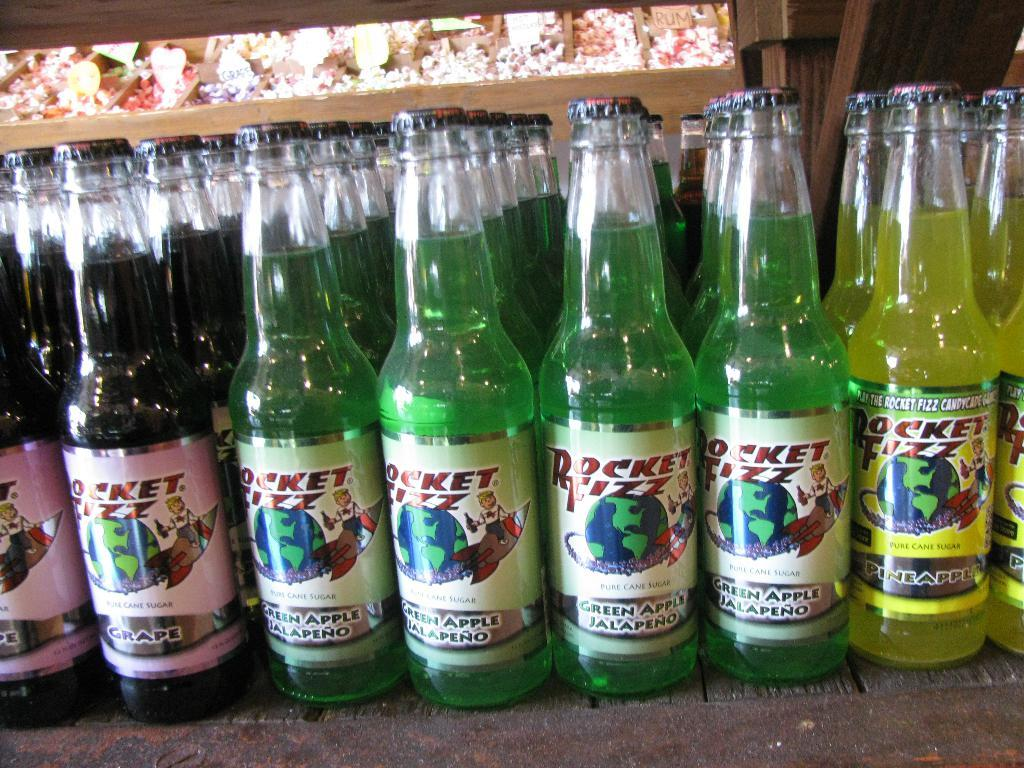<image>
Describe the image concisely. Lots of bottles of three different flavors of rocket fizz. 